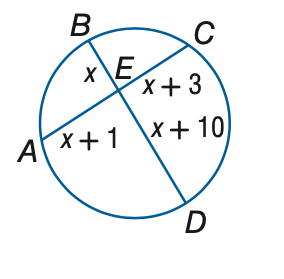Question: Find the measure of x.
Choices:
A. 0.5
B. 1.0
C. 1.5
D. 2.0
Answer with the letter. Answer: A 